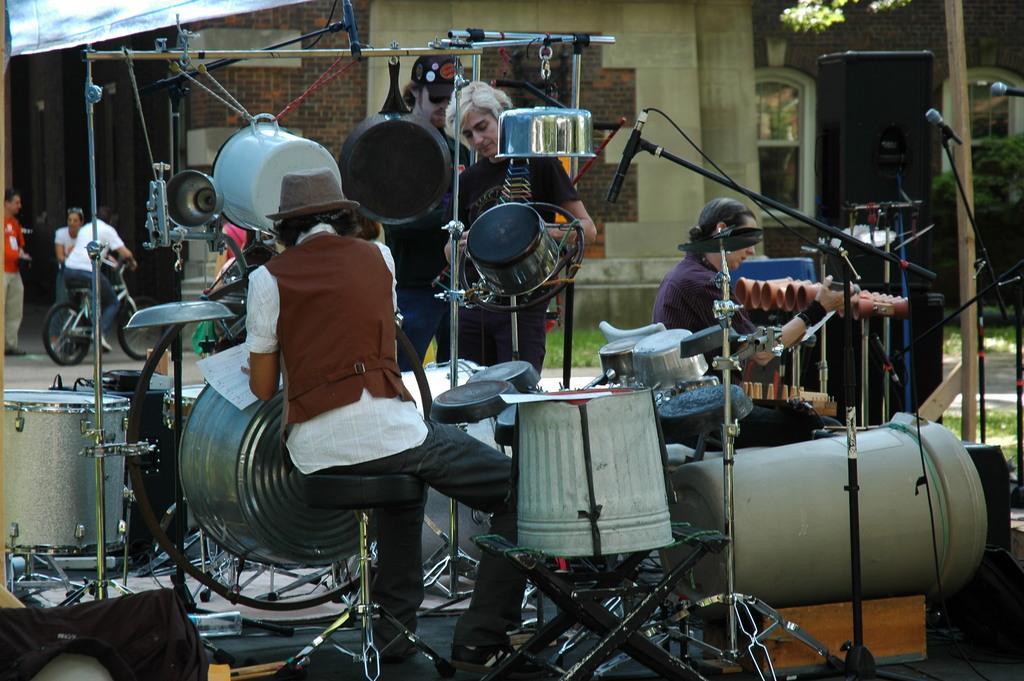How would you summarize this image in a sentence or two? In the picture we can see two people are sitting, two people are standing and touching some objects and around them, we can see some musical instruments and in the background, we can see two people are standing and one person is sitting on the bicycle and beside them we can see the wall of the house. 